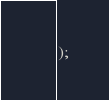<code> <loc_0><loc_0><loc_500><loc_500><_SQL_>);</code> 